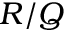Convert formula to latex. <formula><loc_0><loc_0><loc_500><loc_500>R / Q</formula> 